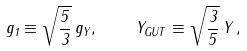Convert formula to latex. <formula><loc_0><loc_0><loc_500><loc_500>g _ { 1 } \equiv \sqrt { \frac { 5 } { 3 } } \, g _ { Y } , \, \quad Y _ { G U T } \equiv \sqrt { \frac { 3 } { 5 } } \, Y \, ,</formula> 